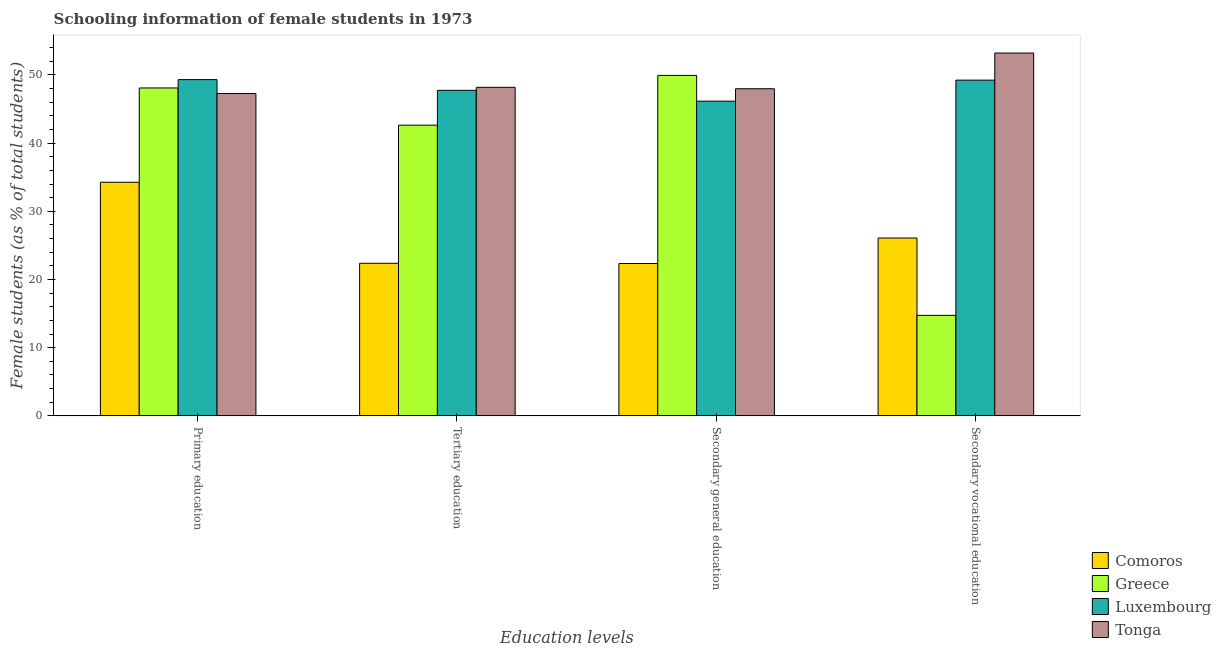How many groups of bars are there?
Ensure brevity in your answer.  4. What is the label of the 3rd group of bars from the left?
Offer a terse response. Secondary general education. What is the percentage of female students in tertiary education in Comoros?
Ensure brevity in your answer.  22.38. Across all countries, what is the maximum percentage of female students in secondary education?
Give a very brief answer. 49.94. Across all countries, what is the minimum percentage of female students in tertiary education?
Give a very brief answer. 22.38. In which country was the percentage of female students in tertiary education maximum?
Provide a short and direct response. Tonga. In which country was the percentage of female students in tertiary education minimum?
Your answer should be compact. Comoros. What is the total percentage of female students in secondary vocational education in the graph?
Ensure brevity in your answer.  143.3. What is the difference between the percentage of female students in primary education in Comoros and that in Greece?
Your response must be concise. -13.83. What is the difference between the percentage of female students in primary education in Tonga and the percentage of female students in secondary education in Comoros?
Give a very brief answer. 24.94. What is the average percentage of female students in primary education per country?
Ensure brevity in your answer.  44.74. What is the difference between the percentage of female students in primary education and percentage of female students in secondary vocational education in Greece?
Make the answer very short. 33.35. In how many countries, is the percentage of female students in secondary vocational education greater than 16 %?
Ensure brevity in your answer.  3. What is the ratio of the percentage of female students in primary education in Tonga to that in Comoros?
Provide a short and direct response. 1.38. Is the percentage of female students in secondary education in Tonga less than that in Luxembourg?
Your answer should be very brief. No. Is the difference between the percentage of female students in tertiary education in Tonga and Comoros greater than the difference between the percentage of female students in secondary vocational education in Tonga and Comoros?
Give a very brief answer. No. What is the difference between the highest and the second highest percentage of female students in secondary vocational education?
Provide a succinct answer. 3.98. What is the difference between the highest and the lowest percentage of female students in secondary education?
Your response must be concise. 27.59. In how many countries, is the percentage of female students in secondary education greater than the average percentage of female students in secondary education taken over all countries?
Your answer should be very brief. 3. Is the sum of the percentage of female students in secondary vocational education in Luxembourg and Greece greater than the maximum percentage of female students in secondary education across all countries?
Offer a terse response. Yes. Is it the case that in every country, the sum of the percentage of female students in secondary vocational education and percentage of female students in tertiary education is greater than the sum of percentage of female students in primary education and percentage of female students in secondary education?
Ensure brevity in your answer.  No. What does the 4th bar from the left in Tertiary education represents?
Give a very brief answer. Tonga. What does the 4th bar from the right in Primary education represents?
Make the answer very short. Comoros. Is it the case that in every country, the sum of the percentage of female students in primary education and percentage of female students in tertiary education is greater than the percentage of female students in secondary education?
Provide a short and direct response. Yes. How many bars are there?
Your answer should be compact. 16. Are all the bars in the graph horizontal?
Ensure brevity in your answer.  No. How many countries are there in the graph?
Give a very brief answer. 4. What is the difference between two consecutive major ticks on the Y-axis?
Provide a succinct answer. 10. Are the values on the major ticks of Y-axis written in scientific E-notation?
Provide a short and direct response. No. Where does the legend appear in the graph?
Your answer should be very brief. Bottom right. How are the legend labels stacked?
Keep it short and to the point. Vertical. What is the title of the graph?
Offer a terse response. Schooling information of female students in 1973. Does "Senegal" appear as one of the legend labels in the graph?
Your answer should be compact. No. What is the label or title of the X-axis?
Provide a succinct answer. Education levels. What is the label or title of the Y-axis?
Your answer should be compact. Female students (as % of total students). What is the Female students (as % of total students) in Comoros in Primary education?
Provide a succinct answer. 34.27. What is the Female students (as % of total students) of Greece in Primary education?
Provide a succinct answer. 48.1. What is the Female students (as % of total students) in Luxembourg in Primary education?
Give a very brief answer. 49.32. What is the Female students (as % of total students) in Tonga in Primary education?
Ensure brevity in your answer.  47.29. What is the Female students (as % of total students) in Comoros in Tertiary education?
Provide a short and direct response. 22.38. What is the Female students (as % of total students) of Greece in Tertiary education?
Provide a succinct answer. 42.64. What is the Female students (as % of total students) of Luxembourg in Tertiary education?
Your answer should be very brief. 47.75. What is the Female students (as % of total students) of Tonga in Tertiary education?
Offer a terse response. 48.19. What is the Female students (as % of total students) of Comoros in Secondary general education?
Ensure brevity in your answer.  22.35. What is the Female students (as % of total students) of Greece in Secondary general education?
Your response must be concise. 49.94. What is the Female students (as % of total students) in Luxembourg in Secondary general education?
Offer a terse response. 46.16. What is the Female students (as % of total students) of Tonga in Secondary general education?
Provide a short and direct response. 47.98. What is the Female students (as % of total students) of Comoros in Secondary vocational education?
Offer a very short reply. 26.09. What is the Female students (as % of total students) of Greece in Secondary vocational education?
Make the answer very short. 14.74. What is the Female students (as % of total students) of Luxembourg in Secondary vocational education?
Provide a succinct answer. 49.24. What is the Female students (as % of total students) of Tonga in Secondary vocational education?
Provide a short and direct response. 53.22. Across all Education levels, what is the maximum Female students (as % of total students) in Comoros?
Keep it short and to the point. 34.27. Across all Education levels, what is the maximum Female students (as % of total students) in Greece?
Provide a succinct answer. 49.94. Across all Education levels, what is the maximum Female students (as % of total students) in Luxembourg?
Provide a succinct answer. 49.32. Across all Education levels, what is the maximum Female students (as % of total students) of Tonga?
Your answer should be very brief. 53.22. Across all Education levels, what is the minimum Female students (as % of total students) of Comoros?
Your answer should be very brief. 22.35. Across all Education levels, what is the minimum Female students (as % of total students) in Greece?
Your answer should be compact. 14.74. Across all Education levels, what is the minimum Female students (as % of total students) of Luxembourg?
Ensure brevity in your answer.  46.16. Across all Education levels, what is the minimum Female students (as % of total students) in Tonga?
Your response must be concise. 47.29. What is the total Female students (as % of total students) in Comoros in the graph?
Give a very brief answer. 105.08. What is the total Female students (as % of total students) in Greece in the graph?
Your response must be concise. 155.42. What is the total Female students (as % of total students) in Luxembourg in the graph?
Ensure brevity in your answer.  192.47. What is the total Female students (as % of total students) of Tonga in the graph?
Give a very brief answer. 196.68. What is the difference between the Female students (as % of total students) of Comoros in Primary education and that in Tertiary education?
Provide a succinct answer. 11.89. What is the difference between the Female students (as % of total students) of Greece in Primary education and that in Tertiary education?
Your answer should be compact. 5.46. What is the difference between the Female students (as % of total students) in Luxembourg in Primary education and that in Tertiary education?
Offer a terse response. 1.57. What is the difference between the Female students (as % of total students) in Tonga in Primary education and that in Tertiary education?
Provide a short and direct response. -0.9. What is the difference between the Female students (as % of total students) in Comoros in Primary education and that in Secondary general education?
Give a very brief answer. 11.92. What is the difference between the Female students (as % of total students) of Greece in Primary education and that in Secondary general education?
Offer a very short reply. -1.84. What is the difference between the Female students (as % of total students) of Luxembourg in Primary education and that in Secondary general education?
Provide a succinct answer. 3.16. What is the difference between the Female students (as % of total students) in Tonga in Primary education and that in Secondary general education?
Ensure brevity in your answer.  -0.7. What is the difference between the Female students (as % of total students) of Comoros in Primary education and that in Secondary vocational education?
Give a very brief answer. 8.18. What is the difference between the Female students (as % of total students) of Greece in Primary education and that in Secondary vocational education?
Ensure brevity in your answer.  33.35. What is the difference between the Female students (as % of total students) in Luxembourg in Primary education and that in Secondary vocational education?
Make the answer very short. 0.07. What is the difference between the Female students (as % of total students) in Tonga in Primary education and that in Secondary vocational education?
Ensure brevity in your answer.  -5.94. What is the difference between the Female students (as % of total students) in Comoros in Tertiary education and that in Secondary general education?
Keep it short and to the point. 0.03. What is the difference between the Female students (as % of total students) of Greece in Tertiary education and that in Secondary general education?
Your answer should be very brief. -7.3. What is the difference between the Female students (as % of total students) in Luxembourg in Tertiary education and that in Secondary general education?
Offer a very short reply. 1.59. What is the difference between the Female students (as % of total students) of Tonga in Tertiary education and that in Secondary general education?
Offer a very short reply. 0.21. What is the difference between the Female students (as % of total students) in Comoros in Tertiary education and that in Secondary vocational education?
Your answer should be compact. -3.71. What is the difference between the Female students (as % of total students) in Greece in Tertiary education and that in Secondary vocational education?
Give a very brief answer. 27.9. What is the difference between the Female students (as % of total students) in Luxembourg in Tertiary education and that in Secondary vocational education?
Your answer should be compact. -1.5. What is the difference between the Female students (as % of total students) in Tonga in Tertiary education and that in Secondary vocational education?
Offer a very short reply. -5.03. What is the difference between the Female students (as % of total students) in Comoros in Secondary general education and that in Secondary vocational education?
Your answer should be compact. -3.74. What is the difference between the Female students (as % of total students) of Greece in Secondary general education and that in Secondary vocational education?
Ensure brevity in your answer.  35.2. What is the difference between the Female students (as % of total students) in Luxembourg in Secondary general education and that in Secondary vocational education?
Offer a very short reply. -3.08. What is the difference between the Female students (as % of total students) in Tonga in Secondary general education and that in Secondary vocational education?
Your answer should be compact. -5.24. What is the difference between the Female students (as % of total students) of Comoros in Primary education and the Female students (as % of total students) of Greece in Tertiary education?
Give a very brief answer. -8.37. What is the difference between the Female students (as % of total students) in Comoros in Primary education and the Female students (as % of total students) in Luxembourg in Tertiary education?
Ensure brevity in your answer.  -13.48. What is the difference between the Female students (as % of total students) in Comoros in Primary education and the Female students (as % of total students) in Tonga in Tertiary education?
Give a very brief answer. -13.92. What is the difference between the Female students (as % of total students) in Greece in Primary education and the Female students (as % of total students) in Luxembourg in Tertiary education?
Ensure brevity in your answer.  0.35. What is the difference between the Female students (as % of total students) of Greece in Primary education and the Female students (as % of total students) of Tonga in Tertiary education?
Provide a short and direct response. -0.09. What is the difference between the Female students (as % of total students) of Luxembourg in Primary education and the Female students (as % of total students) of Tonga in Tertiary education?
Ensure brevity in your answer.  1.13. What is the difference between the Female students (as % of total students) in Comoros in Primary education and the Female students (as % of total students) in Greece in Secondary general education?
Keep it short and to the point. -15.67. What is the difference between the Female students (as % of total students) in Comoros in Primary education and the Female students (as % of total students) in Luxembourg in Secondary general education?
Offer a terse response. -11.89. What is the difference between the Female students (as % of total students) in Comoros in Primary education and the Female students (as % of total students) in Tonga in Secondary general education?
Offer a very short reply. -13.71. What is the difference between the Female students (as % of total students) in Greece in Primary education and the Female students (as % of total students) in Luxembourg in Secondary general education?
Provide a short and direct response. 1.94. What is the difference between the Female students (as % of total students) in Greece in Primary education and the Female students (as % of total students) in Tonga in Secondary general education?
Your answer should be compact. 0.12. What is the difference between the Female students (as % of total students) of Luxembourg in Primary education and the Female students (as % of total students) of Tonga in Secondary general education?
Provide a succinct answer. 1.34. What is the difference between the Female students (as % of total students) of Comoros in Primary education and the Female students (as % of total students) of Greece in Secondary vocational education?
Make the answer very short. 19.52. What is the difference between the Female students (as % of total students) in Comoros in Primary education and the Female students (as % of total students) in Luxembourg in Secondary vocational education?
Give a very brief answer. -14.98. What is the difference between the Female students (as % of total students) of Comoros in Primary education and the Female students (as % of total students) of Tonga in Secondary vocational education?
Your response must be concise. -18.95. What is the difference between the Female students (as % of total students) of Greece in Primary education and the Female students (as % of total students) of Luxembourg in Secondary vocational education?
Provide a succinct answer. -1.15. What is the difference between the Female students (as % of total students) in Greece in Primary education and the Female students (as % of total students) in Tonga in Secondary vocational education?
Your answer should be very brief. -5.12. What is the difference between the Female students (as % of total students) in Luxembourg in Primary education and the Female students (as % of total students) in Tonga in Secondary vocational education?
Provide a succinct answer. -3.9. What is the difference between the Female students (as % of total students) of Comoros in Tertiary education and the Female students (as % of total students) of Greece in Secondary general education?
Offer a very short reply. -27.56. What is the difference between the Female students (as % of total students) of Comoros in Tertiary education and the Female students (as % of total students) of Luxembourg in Secondary general education?
Offer a very short reply. -23.78. What is the difference between the Female students (as % of total students) in Comoros in Tertiary education and the Female students (as % of total students) in Tonga in Secondary general education?
Your answer should be compact. -25.6. What is the difference between the Female students (as % of total students) of Greece in Tertiary education and the Female students (as % of total students) of Luxembourg in Secondary general education?
Your answer should be very brief. -3.52. What is the difference between the Female students (as % of total students) in Greece in Tertiary education and the Female students (as % of total students) in Tonga in Secondary general education?
Make the answer very short. -5.34. What is the difference between the Female students (as % of total students) in Luxembourg in Tertiary education and the Female students (as % of total students) in Tonga in Secondary general education?
Your answer should be very brief. -0.23. What is the difference between the Female students (as % of total students) of Comoros in Tertiary education and the Female students (as % of total students) of Greece in Secondary vocational education?
Keep it short and to the point. 7.64. What is the difference between the Female students (as % of total students) in Comoros in Tertiary education and the Female students (as % of total students) in Luxembourg in Secondary vocational education?
Your answer should be very brief. -26.87. What is the difference between the Female students (as % of total students) in Comoros in Tertiary education and the Female students (as % of total students) in Tonga in Secondary vocational education?
Your response must be concise. -30.84. What is the difference between the Female students (as % of total students) in Greece in Tertiary education and the Female students (as % of total students) in Luxembourg in Secondary vocational education?
Offer a very short reply. -6.61. What is the difference between the Female students (as % of total students) of Greece in Tertiary education and the Female students (as % of total students) of Tonga in Secondary vocational education?
Keep it short and to the point. -10.58. What is the difference between the Female students (as % of total students) of Luxembourg in Tertiary education and the Female students (as % of total students) of Tonga in Secondary vocational education?
Make the answer very short. -5.47. What is the difference between the Female students (as % of total students) in Comoros in Secondary general education and the Female students (as % of total students) in Greece in Secondary vocational education?
Your answer should be very brief. 7.6. What is the difference between the Female students (as % of total students) in Comoros in Secondary general education and the Female students (as % of total students) in Luxembourg in Secondary vocational education?
Give a very brief answer. -26.9. What is the difference between the Female students (as % of total students) of Comoros in Secondary general education and the Female students (as % of total students) of Tonga in Secondary vocational education?
Make the answer very short. -30.88. What is the difference between the Female students (as % of total students) in Greece in Secondary general education and the Female students (as % of total students) in Luxembourg in Secondary vocational education?
Keep it short and to the point. 0.69. What is the difference between the Female students (as % of total students) of Greece in Secondary general education and the Female students (as % of total students) of Tonga in Secondary vocational education?
Provide a short and direct response. -3.28. What is the difference between the Female students (as % of total students) of Luxembourg in Secondary general education and the Female students (as % of total students) of Tonga in Secondary vocational education?
Provide a succinct answer. -7.06. What is the average Female students (as % of total students) of Comoros per Education levels?
Your answer should be very brief. 26.27. What is the average Female students (as % of total students) of Greece per Education levels?
Provide a succinct answer. 38.85. What is the average Female students (as % of total students) of Luxembourg per Education levels?
Ensure brevity in your answer.  48.12. What is the average Female students (as % of total students) of Tonga per Education levels?
Offer a terse response. 49.17. What is the difference between the Female students (as % of total students) of Comoros and Female students (as % of total students) of Greece in Primary education?
Your answer should be compact. -13.83. What is the difference between the Female students (as % of total students) in Comoros and Female students (as % of total students) in Luxembourg in Primary education?
Ensure brevity in your answer.  -15.05. What is the difference between the Female students (as % of total students) in Comoros and Female students (as % of total students) in Tonga in Primary education?
Make the answer very short. -13.02. What is the difference between the Female students (as % of total students) in Greece and Female students (as % of total students) in Luxembourg in Primary education?
Offer a terse response. -1.22. What is the difference between the Female students (as % of total students) of Greece and Female students (as % of total students) of Tonga in Primary education?
Your response must be concise. 0.81. What is the difference between the Female students (as % of total students) of Luxembourg and Female students (as % of total students) of Tonga in Primary education?
Give a very brief answer. 2.03. What is the difference between the Female students (as % of total students) in Comoros and Female students (as % of total students) in Greece in Tertiary education?
Your answer should be very brief. -20.26. What is the difference between the Female students (as % of total students) of Comoros and Female students (as % of total students) of Luxembourg in Tertiary education?
Your response must be concise. -25.37. What is the difference between the Female students (as % of total students) of Comoros and Female students (as % of total students) of Tonga in Tertiary education?
Ensure brevity in your answer.  -25.81. What is the difference between the Female students (as % of total students) of Greece and Female students (as % of total students) of Luxembourg in Tertiary education?
Offer a terse response. -5.11. What is the difference between the Female students (as % of total students) in Greece and Female students (as % of total students) in Tonga in Tertiary education?
Give a very brief answer. -5.55. What is the difference between the Female students (as % of total students) of Luxembourg and Female students (as % of total students) of Tonga in Tertiary education?
Ensure brevity in your answer.  -0.44. What is the difference between the Female students (as % of total students) of Comoros and Female students (as % of total students) of Greece in Secondary general education?
Keep it short and to the point. -27.59. What is the difference between the Female students (as % of total students) of Comoros and Female students (as % of total students) of Luxembourg in Secondary general education?
Offer a very short reply. -23.81. What is the difference between the Female students (as % of total students) of Comoros and Female students (as % of total students) of Tonga in Secondary general education?
Offer a terse response. -25.64. What is the difference between the Female students (as % of total students) in Greece and Female students (as % of total students) in Luxembourg in Secondary general education?
Make the answer very short. 3.78. What is the difference between the Female students (as % of total students) of Greece and Female students (as % of total students) of Tonga in Secondary general education?
Make the answer very short. 1.96. What is the difference between the Female students (as % of total students) in Luxembourg and Female students (as % of total students) in Tonga in Secondary general education?
Your answer should be very brief. -1.82. What is the difference between the Female students (as % of total students) in Comoros and Female students (as % of total students) in Greece in Secondary vocational education?
Keep it short and to the point. 11.34. What is the difference between the Female students (as % of total students) in Comoros and Female students (as % of total students) in Luxembourg in Secondary vocational education?
Offer a very short reply. -23.16. What is the difference between the Female students (as % of total students) of Comoros and Female students (as % of total students) of Tonga in Secondary vocational education?
Give a very brief answer. -27.14. What is the difference between the Female students (as % of total students) of Greece and Female students (as % of total students) of Luxembourg in Secondary vocational education?
Provide a succinct answer. -34.5. What is the difference between the Female students (as % of total students) in Greece and Female students (as % of total students) in Tonga in Secondary vocational education?
Your response must be concise. -38.48. What is the difference between the Female students (as % of total students) of Luxembourg and Female students (as % of total students) of Tonga in Secondary vocational education?
Your response must be concise. -3.98. What is the ratio of the Female students (as % of total students) in Comoros in Primary education to that in Tertiary education?
Make the answer very short. 1.53. What is the ratio of the Female students (as % of total students) in Greece in Primary education to that in Tertiary education?
Give a very brief answer. 1.13. What is the ratio of the Female students (as % of total students) of Luxembourg in Primary education to that in Tertiary education?
Keep it short and to the point. 1.03. What is the ratio of the Female students (as % of total students) of Tonga in Primary education to that in Tertiary education?
Offer a terse response. 0.98. What is the ratio of the Female students (as % of total students) in Comoros in Primary education to that in Secondary general education?
Provide a succinct answer. 1.53. What is the ratio of the Female students (as % of total students) in Greece in Primary education to that in Secondary general education?
Your answer should be compact. 0.96. What is the ratio of the Female students (as % of total students) in Luxembourg in Primary education to that in Secondary general education?
Provide a succinct answer. 1.07. What is the ratio of the Female students (as % of total students) of Tonga in Primary education to that in Secondary general education?
Offer a terse response. 0.99. What is the ratio of the Female students (as % of total students) in Comoros in Primary education to that in Secondary vocational education?
Your answer should be compact. 1.31. What is the ratio of the Female students (as % of total students) in Greece in Primary education to that in Secondary vocational education?
Provide a succinct answer. 3.26. What is the ratio of the Female students (as % of total students) of Tonga in Primary education to that in Secondary vocational education?
Give a very brief answer. 0.89. What is the ratio of the Female students (as % of total students) of Comoros in Tertiary education to that in Secondary general education?
Provide a short and direct response. 1. What is the ratio of the Female students (as % of total students) in Greece in Tertiary education to that in Secondary general education?
Make the answer very short. 0.85. What is the ratio of the Female students (as % of total students) of Luxembourg in Tertiary education to that in Secondary general education?
Your response must be concise. 1.03. What is the ratio of the Female students (as % of total students) in Comoros in Tertiary education to that in Secondary vocational education?
Your response must be concise. 0.86. What is the ratio of the Female students (as % of total students) of Greece in Tertiary education to that in Secondary vocational education?
Offer a terse response. 2.89. What is the ratio of the Female students (as % of total students) in Luxembourg in Tertiary education to that in Secondary vocational education?
Provide a succinct answer. 0.97. What is the ratio of the Female students (as % of total students) in Tonga in Tertiary education to that in Secondary vocational education?
Your answer should be very brief. 0.91. What is the ratio of the Female students (as % of total students) of Comoros in Secondary general education to that in Secondary vocational education?
Provide a short and direct response. 0.86. What is the ratio of the Female students (as % of total students) in Greece in Secondary general education to that in Secondary vocational education?
Give a very brief answer. 3.39. What is the ratio of the Female students (as % of total students) in Luxembourg in Secondary general education to that in Secondary vocational education?
Your answer should be very brief. 0.94. What is the ratio of the Female students (as % of total students) in Tonga in Secondary general education to that in Secondary vocational education?
Ensure brevity in your answer.  0.9. What is the difference between the highest and the second highest Female students (as % of total students) in Comoros?
Give a very brief answer. 8.18. What is the difference between the highest and the second highest Female students (as % of total students) of Greece?
Your answer should be compact. 1.84. What is the difference between the highest and the second highest Female students (as % of total students) in Luxembourg?
Offer a terse response. 0.07. What is the difference between the highest and the second highest Female students (as % of total students) of Tonga?
Your response must be concise. 5.03. What is the difference between the highest and the lowest Female students (as % of total students) in Comoros?
Your answer should be very brief. 11.92. What is the difference between the highest and the lowest Female students (as % of total students) of Greece?
Your answer should be very brief. 35.2. What is the difference between the highest and the lowest Female students (as % of total students) of Luxembourg?
Your response must be concise. 3.16. What is the difference between the highest and the lowest Female students (as % of total students) in Tonga?
Provide a succinct answer. 5.94. 